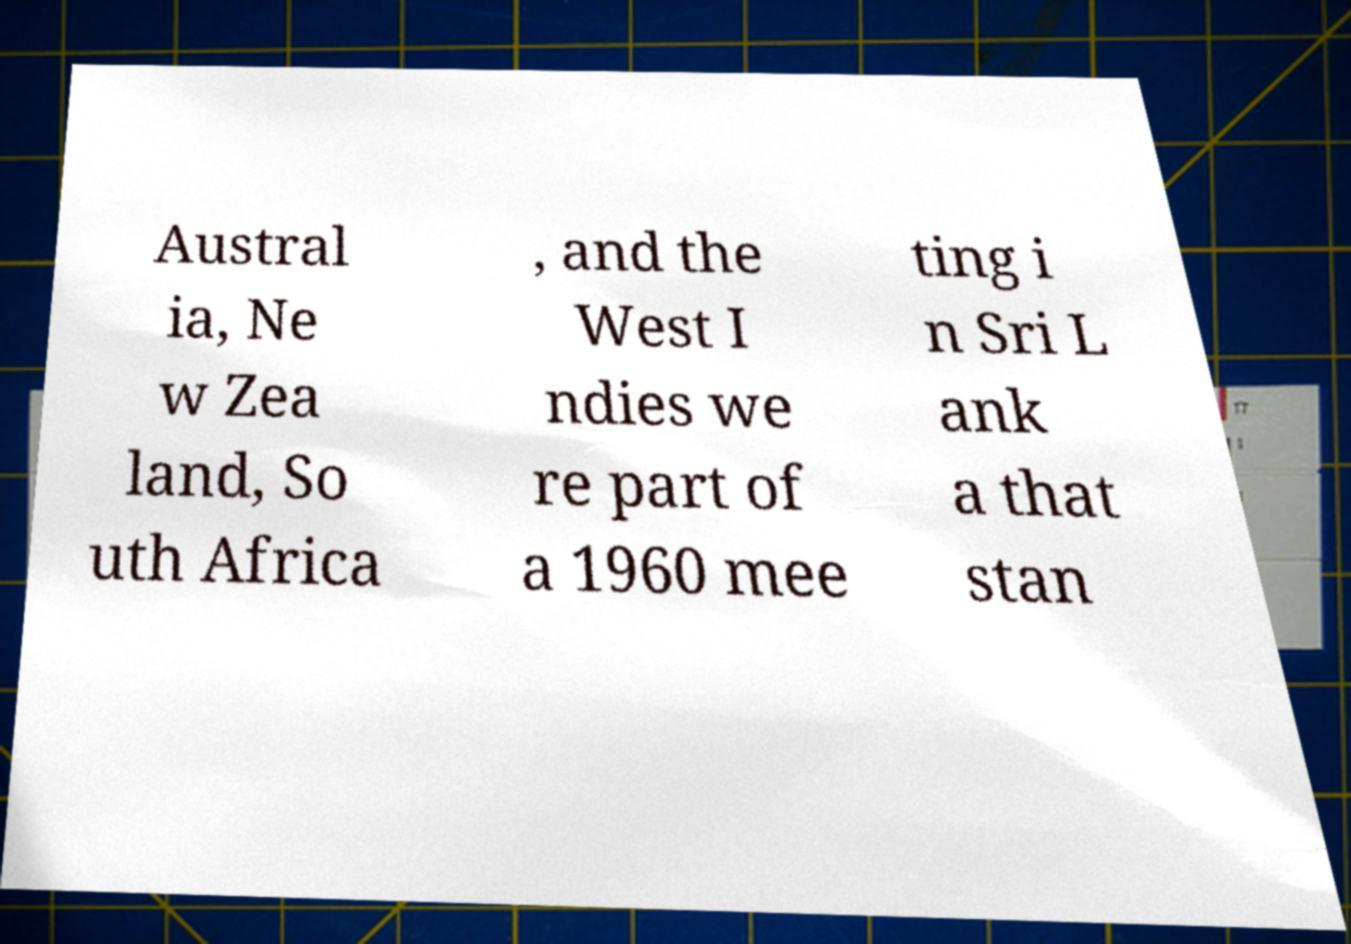Can you accurately transcribe the text from the provided image for me? Austral ia, Ne w Zea land, So uth Africa , and the West I ndies we re part of a 1960 mee ting i n Sri L ank a that stan 